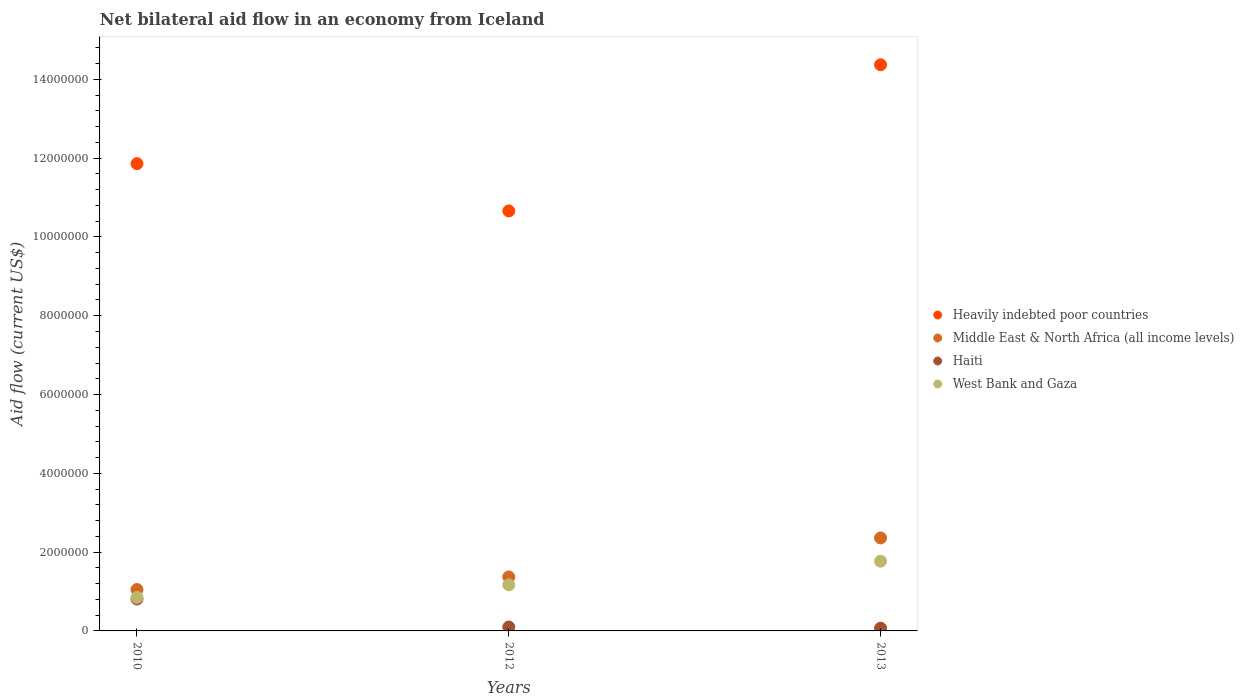How many different coloured dotlines are there?
Keep it short and to the point. 4. What is the net bilateral aid flow in Heavily indebted poor countries in 2012?
Offer a very short reply. 1.07e+07. Across all years, what is the maximum net bilateral aid flow in Haiti?
Give a very brief answer. 8.10e+05. Across all years, what is the minimum net bilateral aid flow in West Bank and Gaza?
Your response must be concise. 8.50e+05. In which year was the net bilateral aid flow in Heavily indebted poor countries minimum?
Your answer should be compact. 2012. What is the total net bilateral aid flow in Heavily indebted poor countries in the graph?
Provide a succinct answer. 3.69e+07. What is the difference between the net bilateral aid flow in Middle East & North Africa (all income levels) in 2010 and that in 2013?
Provide a short and direct response. -1.31e+06. What is the difference between the net bilateral aid flow in Heavily indebted poor countries in 2013 and the net bilateral aid flow in Middle East & North Africa (all income levels) in 2010?
Make the answer very short. 1.33e+07. What is the average net bilateral aid flow in Heavily indebted poor countries per year?
Ensure brevity in your answer.  1.23e+07. In the year 2012, what is the difference between the net bilateral aid flow in Heavily indebted poor countries and net bilateral aid flow in West Bank and Gaza?
Offer a very short reply. 9.49e+06. In how many years, is the net bilateral aid flow in Heavily indebted poor countries greater than 13600000 US$?
Your answer should be very brief. 1. Is the difference between the net bilateral aid flow in Heavily indebted poor countries in 2012 and 2013 greater than the difference between the net bilateral aid flow in West Bank and Gaza in 2012 and 2013?
Provide a short and direct response. No. What is the difference between the highest and the second highest net bilateral aid flow in Heavily indebted poor countries?
Make the answer very short. 2.51e+06. What is the difference between the highest and the lowest net bilateral aid flow in Middle East & North Africa (all income levels)?
Give a very brief answer. 1.31e+06. Is the sum of the net bilateral aid flow in Haiti in 2012 and 2013 greater than the maximum net bilateral aid flow in Heavily indebted poor countries across all years?
Offer a very short reply. No. Does the net bilateral aid flow in Heavily indebted poor countries monotonically increase over the years?
Give a very brief answer. No. Is the net bilateral aid flow in Haiti strictly greater than the net bilateral aid flow in Heavily indebted poor countries over the years?
Your answer should be very brief. No. How many dotlines are there?
Offer a terse response. 4. How many years are there in the graph?
Your answer should be very brief. 3. Are the values on the major ticks of Y-axis written in scientific E-notation?
Your answer should be compact. No. Does the graph contain any zero values?
Give a very brief answer. No. Does the graph contain grids?
Make the answer very short. No. How many legend labels are there?
Ensure brevity in your answer.  4. How are the legend labels stacked?
Provide a short and direct response. Vertical. What is the title of the graph?
Your answer should be very brief. Net bilateral aid flow in an economy from Iceland. What is the label or title of the Y-axis?
Provide a short and direct response. Aid flow (current US$). What is the Aid flow (current US$) in Heavily indebted poor countries in 2010?
Offer a terse response. 1.19e+07. What is the Aid flow (current US$) of Middle East & North Africa (all income levels) in 2010?
Your response must be concise. 1.05e+06. What is the Aid flow (current US$) in Haiti in 2010?
Give a very brief answer. 8.10e+05. What is the Aid flow (current US$) in West Bank and Gaza in 2010?
Your response must be concise. 8.50e+05. What is the Aid flow (current US$) in Heavily indebted poor countries in 2012?
Keep it short and to the point. 1.07e+07. What is the Aid flow (current US$) of Middle East & North Africa (all income levels) in 2012?
Keep it short and to the point. 1.37e+06. What is the Aid flow (current US$) of West Bank and Gaza in 2012?
Your answer should be very brief. 1.17e+06. What is the Aid flow (current US$) of Heavily indebted poor countries in 2013?
Your answer should be compact. 1.44e+07. What is the Aid flow (current US$) of Middle East & North Africa (all income levels) in 2013?
Keep it short and to the point. 2.36e+06. What is the Aid flow (current US$) in Haiti in 2013?
Provide a short and direct response. 7.00e+04. What is the Aid flow (current US$) in West Bank and Gaza in 2013?
Give a very brief answer. 1.77e+06. Across all years, what is the maximum Aid flow (current US$) in Heavily indebted poor countries?
Keep it short and to the point. 1.44e+07. Across all years, what is the maximum Aid flow (current US$) in Middle East & North Africa (all income levels)?
Keep it short and to the point. 2.36e+06. Across all years, what is the maximum Aid flow (current US$) in Haiti?
Provide a short and direct response. 8.10e+05. Across all years, what is the maximum Aid flow (current US$) of West Bank and Gaza?
Your response must be concise. 1.77e+06. Across all years, what is the minimum Aid flow (current US$) in Heavily indebted poor countries?
Your answer should be compact. 1.07e+07. Across all years, what is the minimum Aid flow (current US$) of Middle East & North Africa (all income levels)?
Give a very brief answer. 1.05e+06. Across all years, what is the minimum Aid flow (current US$) in West Bank and Gaza?
Your answer should be compact. 8.50e+05. What is the total Aid flow (current US$) in Heavily indebted poor countries in the graph?
Ensure brevity in your answer.  3.69e+07. What is the total Aid flow (current US$) in Middle East & North Africa (all income levels) in the graph?
Make the answer very short. 4.78e+06. What is the total Aid flow (current US$) in Haiti in the graph?
Offer a very short reply. 9.80e+05. What is the total Aid flow (current US$) in West Bank and Gaza in the graph?
Make the answer very short. 3.79e+06. What is the difference between the Aid flow (current US$) of Heavily indebted poor countries in 2010 and that in 2012?
Provide a short and direct response. 1.20e+06. What is the difference between the Aid flow (current US$) in Middle East & North Africa (all income levels) in 2010 and that in 2012?
Provide a short and direct response. -3.20e+05. What is the difference between the Aid flow (current US$) of Haiti in 2010 and that in 2012?
Provide a short and direct response. 7.10e+05. What is the difference between the Aid flow (current US$) of West Bank and Gaza in 2010 and that in 2012?
Make the answer very short. -3.20e+05. What is the difference between the Aid flow (current US$) of Heavily indebted poor countries in 2010 and that in 2013?
Make the answer very short. -2.51e+06. What is the difference between the Aid flow (current US$) in Middle East & North Africa (all income levels) in 2010 and that in 2013?
Give a very brief answer. -1.31e+06. What is the difference between the Aid flow (current US$) of Haiti in 2010 and that in 2013?
Your response must be concise. 7.40e+05. What is the difference between the Aid flow (current US$) in West Bank and Gaza in 2010 and that in 2013?
Provide a succinct answer. -9.20e+05. What is the difference between the Aid flow (current US$) in Heavily indebted poor countries in 2012 and that in 2013?
Ensure brevity in your answer.  -3.71e+06. What is the difference between the Aid flow (current US$) of Middle East & North Africa (all income levels) in 2012 and that in 2013?
Make the answer very short. -9.90e+05. What is the difference between the Aid flow (current US$) in Haiti in 2012 and that in 2013?
Make the answer very short. 3.00e+04. What is the difference between the Aid flow (current US$) of West Bank and Gaza in 2012 and that in 2013?
Provide a succinct answer. -6.00e+05. What is the difference between the Aid flow (current US$) in Heavily indebted poor countries in 2010 and the Aid flow (current US$) in Middle East & North Africa (all income levels) in 2012?
Offer a very short reply. 1.05e+07. What is the difference between the Aid flow (current US$) in Heavily indebted poor countries in 2010 and the Aid flow (current US$) in Haiti in 2012?
Your response must be concise. 1.18e+07. What is the difference between the Aid flow (current US$) of Heavily indebted poor countries in 2010 and the Aid flow (current US$) of West Bank and Gaza in 2012?
Provide a short and direct response. 1.07e+07. What is the difference between the Aid flow (current US$) of Middle East & North Africa (all income levels) in 2010 and the Aid flow (current US$) of Haiti in 2012?
Your answer should be very brief. 9.50e+05. What is the difference between the Aid flow (current US$) of Haiti in 2010 and the Aid flow (current US$) of West Bank and Gaza in 2012?
Ensure brevity in your answer.  -3.60e+05. What is the difference between the Aid flow (current US$) in Heavily indebted poor countries in 2010 and the Aid flow (current US$) in Middle East & North Africa (all income levels) in 2013?
Your answer should be very brief. 9.50e+06. What is the difference between the Aid flow (current US$) in Heavily indebted poor countries in 2010 and the Aid flow (current US$) in Haiti in 2013?
Offer a terse response. 1.18e+07. What is the difference between the Aid flow (current US$) of Heavily indebted poor countries in 2010 and the Aid flow (current US$) of West Bank and Gaza in 2013?
Provide a short and direct response. 1.01e+07. What is the difference between the Aid flow (current US$) of Middle East & North Africa (all income levels) in 2010 and the Aid flow (current US$) of Haiti in 2013?
Keep it short and to the point. 9.80e+05. What is the difference between the Aid flow (current US$) of Middle East & North Africa (all income levels) in 2010 and the Aid flow (current US$) of West Bank and Gaza in 2013?
Offer a terse response. -7.20e+05. What is the difference between the Aid flow (current US$) in Haiti in 2010 and the Aid flow (current US$) in West Bank and Gaza in 2013?
Ensure brevity in your answer.  -9.60e+05. What is the difference between the Aid flow (current US$) of Heavily indebted poor countries in 2012 and the Aid flow (current US$) of Middle East & North Africa (all income levels) in 2013?
Offer a very short reply. 8.30e+06. What is the difference between the Aid flow (current US$) of Heavily indebted poor countries in 2012 and the Aid flow (current US$) of Haiti in 2013?
Provide a succinct answer. 1.06e+07. What is the difference between the Aid flow (current US$) of Heavily indebted poor countries in 2012 and the Aid flow (current US$) of West Bank and Gaza in 2013?
Your answer should be compact. 8.89e+06. What is the difference between the Aid flow (current US$) of Middle East & North Africa (all income levels) in 2012 and the Aid flow (current US$) of Haiti in 2013?
Your answer should be compact. 1.30e+06. What is the difference between the Aid flow (current US$) in Middle East & North Africa (all income levels) in 2012 and the Aid flow (current US$) in West Bank and Gaza in 2013?
Give a very brief answer. -4.00e+05. What is the difference between the Aid flow (current US$) of Haiti in 2012 and the Aid flow (current US$) of West Bank and Gaza in 2013?
Keep it short and to the point. -1.67e+06. What is the average Aid flow (current US$) of Heavily indebted poor countries per year?
Offer a terse response. 1.23e+07. What is the average Aid flow (current US$) of Middle East & North Africa (all income levels) per year?
Keep it short and to the point. 1.59e+06. What is the average Aid flow (current US$) of Haiti per year?
Provide a succinct answer. 3.27e+05. What is the average Aid flow (current US$) in West Bank and Gaza per year?
Provide a short and direct response. 1.26e+06. In the year 2010, what is the difference between the Aid flow (current US$) in Heavily indebted poor countries and Aid flow (current US$) in Middle East & North Africa (all income levels)?
Provide a short and direct response. 1.08e+07. In the year 2010, what is the difference between the Aid flow (current US$) in Heavily indebted poor countries and Aid flow (current US$) in Haiti?
Give a very brief answer. 1.10e+07. In the year 2010, what is the difference between the Aid flow (current US$) in Heavily indebted poor countries and Aid flow (current US$) in West Bank and Gaza?
Offer a terse response. 1.10e+07. In the year 2010, what is the difference between the Aid flow (current US$) of Middle East & North Africa (all income levels) and Aid flow (current US$) of West Bank and Gaza?
Make the answer very short. 2.00e+05. In the year 2012, what is the difference between the Aid flow (current US$) in Heavily indebted poor countries and Aid flow (current US$) in Middle East & North Africa (all income levels)?
Your answer should be very brief. 9.29e+06. In the year 2012, what is the difference between the Aid flow (current US$) of Heavily indebted poor countries and Aid flow (current US$) of Haiti?
Keep it short and to the point. 1.06e+07. In the year 2012, what is the difference between the Aid flow (current US$) in Heavily indebted poor countries and Aid flow (current US$) in West Bank and Gaza?
Provide a succinct answer. 9.49e+06. In the year 2012, what is the difference between the Aid flow (current US$) in Middle East & North Africa (all income levels) and Aid flow (current US$) in Haiti?
Ensure brevity in your answer.  1.27e+06. In the year 2012, what is the difference between the Aid flow (current US$) of Middle East & North Africa (all income levels) and Aid flow (current US$) of West Bank and Gaza?
Your answer should be compact. 2.00e+05. In the year 2012, what is the difference between the Aid flow (current US$) of Haiti and Aid flow (current US$) of West Bank and Gaza?
Give a very brief answer. -1.07e+06. In the year 2013, what is the difference between the Aid flow (current US$) of Heavily indebted poor countries and Aid flow (current US$) of Middle East & North Africa (all income levels)?
Provide a succinct answer. 1.20e+07. In the year 2013, what is the difference between the Aid flow (current US$) of Heavily indebted poor countries and Aid flow (current US$) of Haiti?
Keep it short and to the point. 1.43e+07. In the year 2013, what is the difference between the Aid flow (current US$) of Heavily indebted poor countries and Aid flow (current US$) of West Bank and Gaza?
Ensure brevity in your answer.  1.26e+07. In the year 2013, what is the difference between the Aid flow (current US$) in Middle East & North Africa (all income levels) and Aid flow (current US$) in Haiti?
Give a very brief answer. 2.29e+06. In the year 2013, what is the difference between the Aid flow (current US$) of Middle East & North Africa (all income levels) and Aid flow (current US$) of West Bank and Gaza?
Make the answer very short. 5.90e+05. In the year 2013, what is the difference between the Aid flow (current US$) in Haiti and Aid flow (current US$) in West Bank and Gaza?
Offer a very short reply. -1.70e+06. What is the ratio of the Aid flow (current US$) in Heavily indebted poor countries in 2010 to that in 2012?
Offer a very short reply. 1.11. What is the ratio of the Aid flow (current US$) of Middle East & North Africa (all income levels) in 2010 to that in 2012?
Your answer should be compact. 0.77. What is the ratio of the Aid flow (current US$) of West Bank and Gaza in 2010 to that in 2012?
Give a very brief answer. 0.73. What is the ratio of the Aid flow (current US$) in Heavily indebted poor countries in 2010 to that in 2013?
Provide a succinct answer. 0.83. What is the ratio of the Aid flow (current US$) in Middle East & North Africa (all income levels) in 2010 to that in 2013?
Your answer should be very brief. 0.44. What is the ratio of the Aid flow (current US$) of Haiti in 2010 to that in 2013?
Make the answer very short. 11.57. What is the ratio of the Aid flow (current US$) of West Bank and Gaza in 2010 to that in 2013?
Offer a very short reply. 0.48. What is the ratio of the Aid flow (current US$) in Heavily indebted poor countries in 2012 to that in 2013?
Your answer should be compact. 0.74. What is the ratio of the Aid flow (current US$) of Middle East & North Africa (all income levels) in 2012 to that in 2013?
Your answer should be compact. 0.58. What is the ratio of the Aid flow (current US$) in Haiti in 2012 to that in 2013?
Ensure brevity in your answer.  1.43. What is the ratio of the Aid flow (current US$) of West Bank and Gaza in 2012 to that in 2013?
Offer a very short reply. 0.66. What is the difference between the highest and the second highest Aid flow (current US$) in Heavily indebted poor countries?
Keep it short and to the point. 2.51e+06. What is the difference between the highest and the second highest Aid flow (current US$) in Middle East & North Africa (all income levels)?
Provide a short and direct response. 9.90e+05. What is the difference between the highest and the second highest Aid flow (current US$) of Haiti?
Your answer should be very brief. 7.10e+05. What is the difference between the highest and the lowest Aid flow (current US$) in Heavily indebted poor countries?
Give a very brief answer. 3.71e+06. What is the difference between the highest and the lowest Aid flow (current US$) of Middle East & North Africa (all income levels)?
Your response must be concise. 1.31e+06. What is the difference between the highest and the lowest Aid flow (current US$) in Haiti?
Offer a terse response. 7.40e+05. What is the difference between the highest and the lowest Aid flow (current US$) of West Bank and Gaza?
Your answer should be very brief. 9.20e+05. 